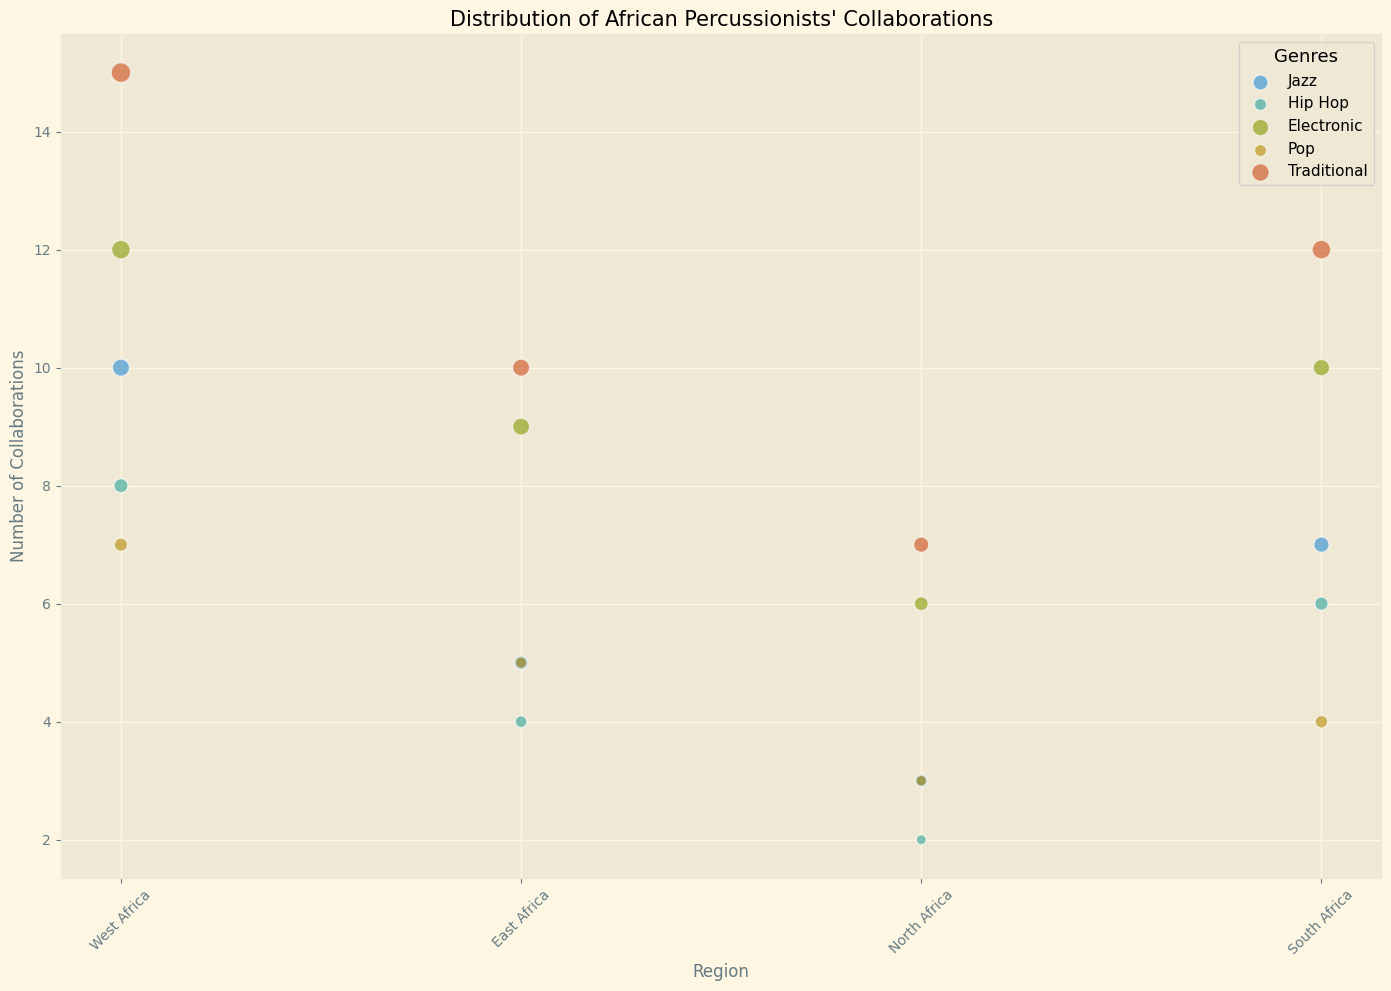Which genre has the highest number of collaborations in West Africa? By observing the chart, find the bubble corresponding to West Africa and the genre that has the highest y-axis value. The genre for this bubble will be the one with the most collaborations.
Answer: Traditional Which genre has the lowest number of collaborations in North Africa? Find the bubble corresponding to North Africa and the genre that sits at the lowest point on the y-axis.
Answer: Hip Hop How many more collaborations are there for Electronic music in East Africa compared to Jazz in the same region? Find the East Africa bubbles for Electronic and Jazz genres. Subtract the Jazz collaborations from the Electronic collaborations. (9 - 5 = 4)
Answer: 4 What is the median number of collaborations for all genres in South Africa? List the number of collaborations for all genres in South Africa. The values are: 7, 6, 10, 4, 12. Arrange them in ascending order: 4, 6, 7, 10, 12. The middle value (median) is 7.
Answer: 7 Which genre has the largest bubble size in East Africa? Look for the largest bubble size in East Africa and identify its corresponding genre.
Answer: Traditional Between Hip Hop and Pop, which genre has more collaborations in West Africa? Compare the y-axis values of Hip Hop and Pop genres for West Africa. The value for Hip Hop is 8 and for Pop is 7. Hip Hop has more collaborations.
Answer: Hip Hop Is the number of collaborations for Pop in South Africa greater than Jazz in East Africa? Find the number of collaborations for Pop in South Africa (4) and for Jazz in East Africa (5). Compare the two values.
Answer: No Which regions have exactly 10 collaborations for the Jazz genre? Locate the bubbles for the Jazz genre and identify the regions where the y-axis value is 10.
Answer: West Africa How many genres have more than 10 collaborations in West Africa? Check the y-axis values for each genre in West Africa: Jazz (10), Hip Hop (8), Electronic (12), Pop (7), Traditional (15). Count the genres where more than 10 collaborations are present: Electronic and Traditional.
Answer: 2 In which region does Traditional music have the least number of collaborations? Search the y-axis values for the Traditional genre across all regions and identify the smallest value. The least number is 7 in North Africa.
Answer: North Africa 